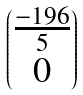<formula> <loc_0><loc_0><loc_500><loc_500>\begin{pmatrix} \frac { - 1 9 6 } { 5 } \\ 0 \end{pmatrix}</formula> 